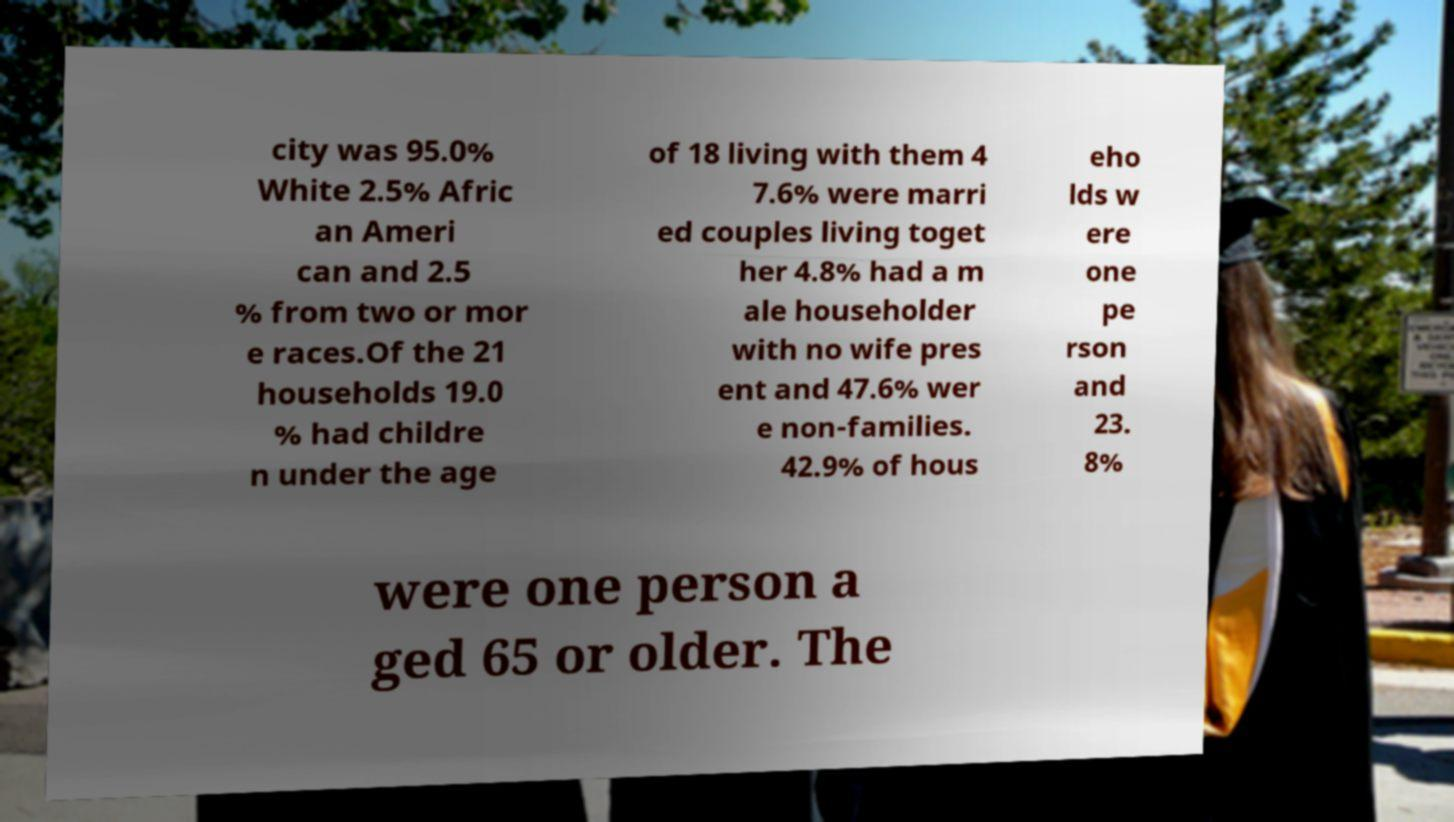Can you read and provide the text displayed in the image?This photo seems to have some interesting text. Can you extract and type it out for me? city was 95.0% White 2.5% Afric an Ameri can and 2.5 % from two or mor e races.Of the 21 households 19.0 % had childre n under the age of 18 living with them 4 7.6% were marri ed couples living toget her 4.8% had a m ale householder with no wife pres ent and 47.6% wer e non-families. 42.9% of hous eho lds w ere one pe rson and 23. 8% were one person a ged 65 or older. The 